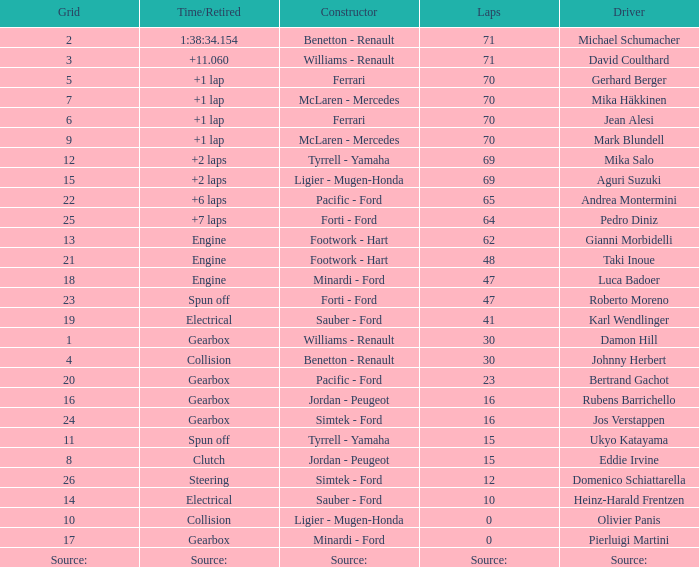Write the full table. {'header': ['Grid', 'Time/Retired', 'Constructor', 'Laps', 'Driver'], 'rows': [['2', '1:38:34.154', 'Benetton - Renault', '71', 'Michael Schumacher'], ['3', '+11.060', 'Williams - Renault', '71', 'David Coulthard'], ['5', '+1 lap', 'Ferrari', '70', 'Gerhard Berger'], ['7', '+1 lap', 'McLaren - Mercedes', '70', 'Mika Häkkinen'], ['6', '+1 lap', 'Ferrari', '70', 'Jean Alesi'], ['9', '+1 lap', 'McLaren - Mercedes', '70', 'Mark Blundell'], ['12', '+2 laps', 'Tyrrell - Yamaha', '69', 'Mika Salo'], ['15', '+2 laps', 'Ligier - Mugen-Honda', '69', 'Aguri Suzuki'], ['22', '+6 laps', 'Pacific - Ford', '65', 'Andrea Montermini'], ['25', '+7 laps', 'Forti - Ford', '64', 'Pedro Diniz'], ['13', 'Engine', 'Footwork - Hart', '62', 'Gianni Morbidelli'], ['21', 'Engine', 'Footwork - Hart', '48', 'Taki Inoue'], ['18', 'Engine', 'Minardi - Ford', '47', 'Luca Badoer'], ['23', 'Spun off', 'Forti - Ford', '47', 'Roberto Moreno'], ['19', 'Electrical', 'Sauber - Ford', '41', 'Karl Wendlinger'], ['1', 'Gearbox', 'Williams - Renault', '30', 'Damon Hill'], ['4', 'Collision', 'Benetton - Renault', '30', 'Johnny Herbert'], ['20', 'Gearbox', 'Pacific - Ford', '23', 'Bertrand Gachot'], ['16', 'Gearbox', 'Jordan - Peugeot', '16', 'Rubens Barrichello'], ['24', 'Gearbox', 'Simtek - Ford', '16', 'Jos Verstappen'], ['11', 'Spun off', 'Tyrrell - Yamaha', '15', 'Ukyo Katayama'], ['8', 'Clutch', 'Jordan - Peugeot', '15', 'Eddie Irvine'], ['26', 'Steering', 'Simtek - Ford', '12', 'Domenico Schiattarella'], ['14', 'Electrical', 'Sauber - Ford', '10', 'Heinz-Harald Frentzen'], ['10', 'Collision', 'Ligier - Mugen-Honda', '0', 'Olivier Panis'], ['17', 'Gearbox', 'Minardi - Ford', '0', 'Pierluigi Martini'], ['Source:', 'Source:', 'Source:', 'Source:', 'Source:']]} How many laps were there in grid 21? 48.0. 